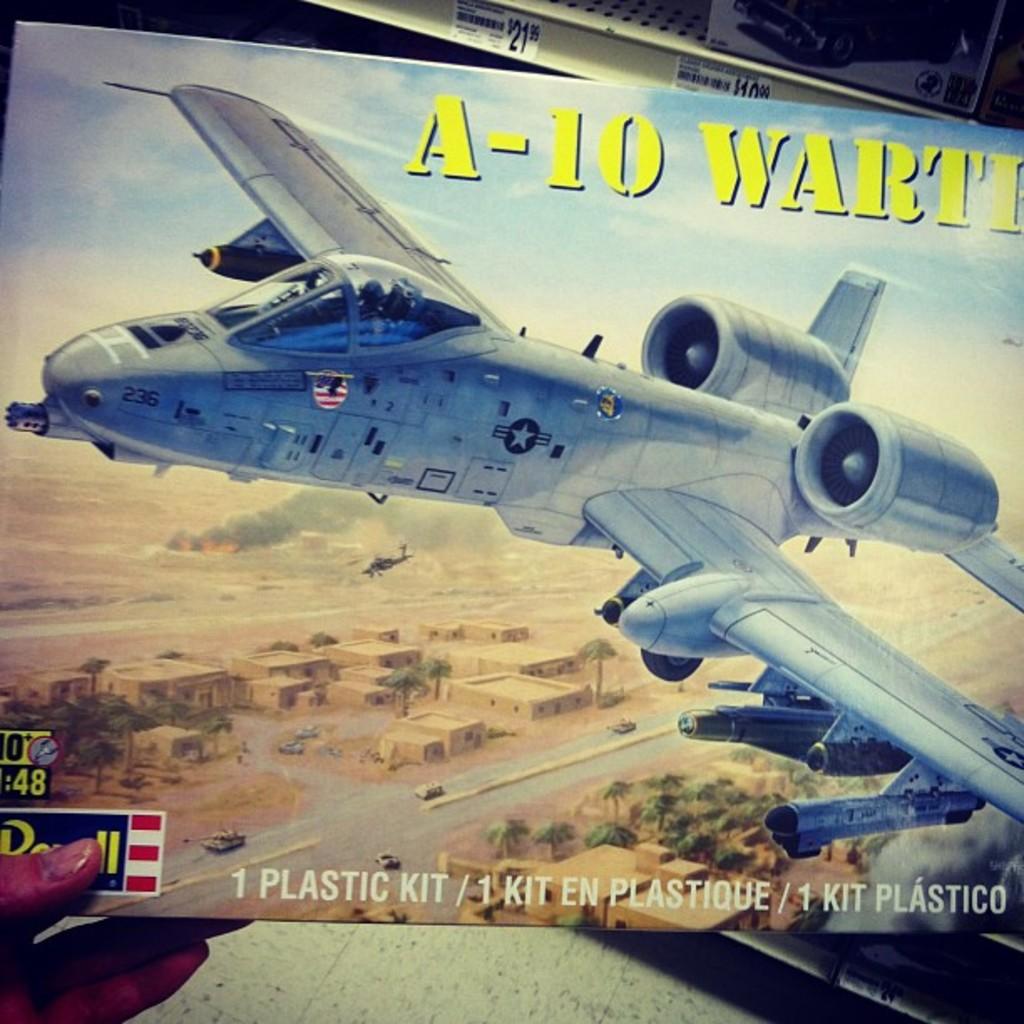What kind of kit is in the box?
Your answer should be very brief. Plastic. What is the three numbers on the nose of the plane?
Ensure brevity in your answer.  236. 